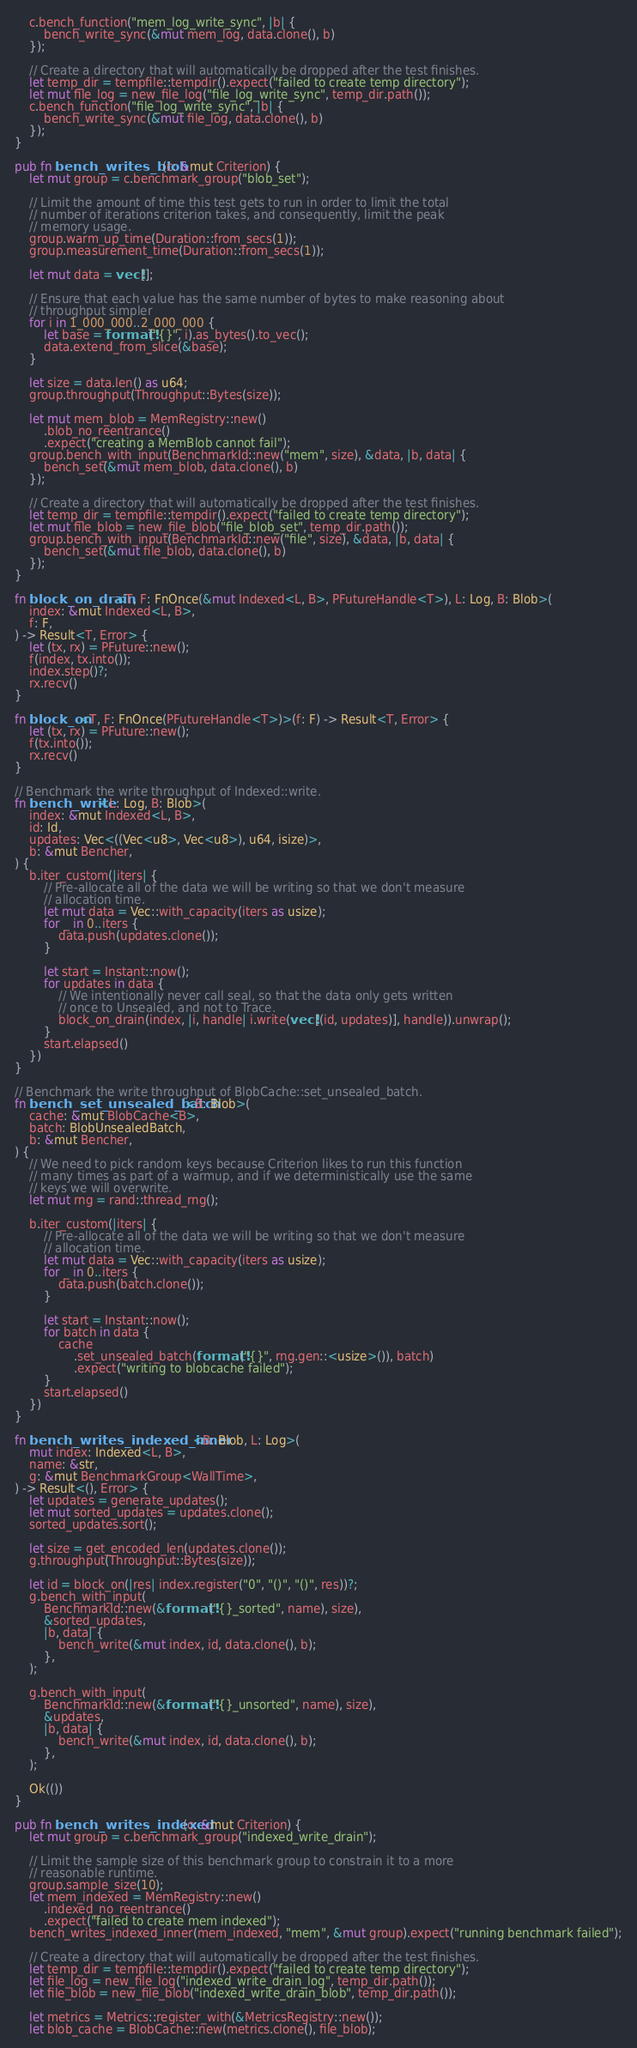<code> <loc_0><loc_0><loc_500><loc_500><_Rust_>    c.bench_function("mem_log_write_sync", |b| {
        bench_write_sync(&mut mem_log, data.clone(), b)
    });

    // Create a directory that will automatically be dropped after the test finishes.
    let temp_dir = tempfile::tempdir().expect("failed to create temp directory");
    let mut file_log = new_file_log("file_log_write_sync", temp_dir.path());
    c.bench_function("file_log_write_sync", |b| {
        bench_write_sync(&mut file_log, data.clone(), b)
    });
}

pub fn bench_writes_blob(c: &mut Criterion) {
    let mut group = c.benchmark_group("blob_set");

    // Limit the amount of time this test gets to run in order to limit the total
    // number of iterations criterion takes, and consequently, limit the peak
    // memory usage.
    group.warm_up_time(Duration::from_secs(1));
    group.measurement_time(Duration::from_secs(1));

    let mut data = vec![];

    // Ensure that each value has the same number of bytes to make reasoning about
    // throughput simpler
    for i in 1_000_000..2_000_000 {
        let base = format!("{}", i).as_bytes().to_vec();
        data.extend_from_slice(&base);
    }

    let size = data.len() as u64;
    group.throughput(Throughput::Bytes(size));

    let mut mem_blob = MemRegistry::new()
        .blob_no_reentrance()
        .expect("creating a MemBlob cannot fail");
    group.bench_with_input(BenchmarkId::new("mem", size), &data, |b, data| {
        bench_set(&mut mem_blob, data.clone(), b)
    });

    // Create a directory that will automatically be dropped after the test finishes.
    let temp_dir = tempfile::tempdir().expect("failed to create temp directory");
    let mut file_blob = new_file_blob("file_blob_set", temp_dir.path());
    group.bench_with_input(BenchmarkId::new("file", size), &data, |b, data| {
        bench_set(&mut file_blob, data.clone(), b)
    });
}

fn block_on_drain<T, F: FnOnce(&mut Indexed<L, B>, PFutureHandle<T>), L: Log, B: Blob>(
    index: &mut Indexed<L, B>,
    f: F,
) -> Result<T, Error> {
    let (tx, rx) = PFuture::new();
    f(index, tx.into());
    index.step()?;
    rx.recv()
}

fn block_on<T, F: FnOnce(PFutureHandle<T>)>(f: F) -> Result<T, Error> {
    let (tx, rx) = PFuture::new();
    f(tx.into());
    rx.recv()
}

// Benchmark the write throughput of Indexed::write.
fn bench_write<L: Log, B: Blob>(
    index: &mut Indexed<L, B>,
    id: Id,
    updates: Vec<((Vec<u8>, Vec<u8>), u64, isize)>,
    b: &mut Bencher,
) {
    b.iter_custom(|iters| {
        // Pre-allocate all of the data we will be writing so that we don't measure
        // allocation time.
        let mut data = Vec::with_capacity(iters as usize);
        for _ in 0..iters {
            data.push(updates.clone());
        }

        let start = Instant::now();
        for updates in data {
            // We intentionally never call seal, so that the data only gets written
            // once to Unsealed, and not to Trace.
            block_on_drain(index, |i, handle| i.write(vec![(id, updates)], handle)).unwrap();
        }
        start.elapsed()
    })
}

// Benchmark the write throughput of BlobCache::set_unsealed_batch.
fn bench_set_unsealed_batch<B: Blob>(
    cache: &mut BlobCache<B>,
    batch: BlobUnsealedBatch,
    b: &mut Bencher,
) {
    // We need to pick random keys because Criterion likes to run this function
    // many times as part of a warmup, and if we deterministically use the same
    // keys we will overwrite.
    let mut rng = rand::thread_rng();

    b.iter_custom(|iters| {
        // Pre-allocate all of the data we will be writing so that we don't measure
        // allocation time.
        let mut data = Vec::with_capacity(iters as usize);
        for _ in 0..iters {
            data.push(batch.clone());
        }

        let start = Instant::now();
        for batch in data {
            cache
                .set_unsealed_batch(format!("{}", rng.gen::<usize>()), batch)
                .expect("writing to blobcache failed");
        }
        start.elapsed()
    })
}

fn bench_writes_indexed_inner<B: Blob, L: Log>(
    mut index: Indexed<L, B>,
    name: &str,
    g: &mut BenchmarkGroup<WallTime>,
) -> Result<(), Error> {
    let updates = generate_updates();
    let mut sorted_updates = updates.clone();
    sorted_updates.sort();

    let size = get_encoded_len(updates.clone());
    g.throughput(Throughput::Bytes(size));

    let id = block_on(|res| index.register("0", "()", "()", res))?;
    g.bench_with_input(
        BenchmarkId::new(&format!("{}_sorted", name), size),
        &sorted_updates,
        |b, data| {
            bench_write(&mut index, id, data.clone(), b);
        },
    );

    g.bench_with_input(
        BenchmarkId::new(&format!("{}_unsorted", name), size),
        &updates,
        |b, data| {
            bench_write(&mut index, id, data.clone(), b);
        },
    );

    Ok(())
}

pub fn bench_writes_indexed(c: &mut Criterion) {
    let mut group = c.benchmark_group("indexed_write_drain");

    // Limit the sample size of this benchmark group to constrain it to a more
    // reasonable runtime.
    group.sample_size(10);
    let mem_indexed = MemRegistry::new()
        .indexed_no_reentrance()
        .expect("failed to create mem indexed");
    bench_writes_indexed_inner(mem_indexed, "mem", &mut group).expect("running benchmark failed");

    // Create a directory that will automatically be dropped after the test finishes.
    let temp_dir = tempfile::tempdir().expect("failed to create temp directory");
    let file_log = new_file_log("indexed_write_drain_log", temp_dir.path());
    let file_blob = new_file_blob("indexed_write_drain_blob", temp_dir.path());

    let metrics = Metrics::register_with(&MetricsRegistry::new());
    let blob_cache = BlobCache::new(metrics.clone(), file_blob);</code> 